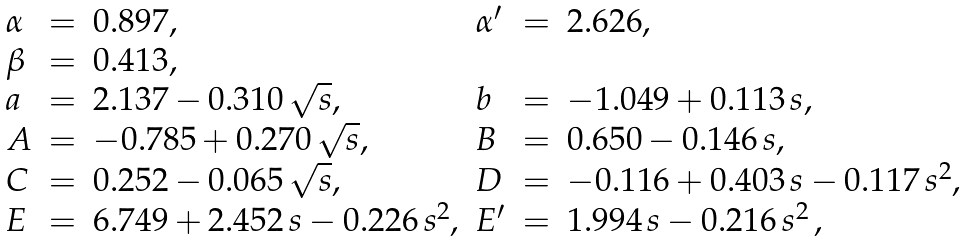Convert formula to latex. <formula><loc_0><loc_0><loc_500><loc_500>\begin{array} { l c l l c l } { \alpha } & { = } & { 0 . 8 9 7 , } & { { \alpha ^ { \prime } } } & { = } & { 2 . 6 2 6 , } \\ { \beta } & { = } & { 0 . 4 1 3 , } \\ { a } & { = } & { { 2 . 1 3 7 - 0 . 3 1 0 \, \sqrt { s } , } } & { b } & { = } & { - 1 . 0 4 9 + 0 . 1 1 3 \, s , } \\ { A } & { = } & { { - 0 . 7 8 5 + 0 . 2 7 0 \, \sqrt { s } , } } & { B } & { = } & { 0 . 6 5 0 - 0 . 1 4 6 \, s , } \\ { C } & { = } & { { 0 . 2 5 2 - 0 . 0 6 5 \, \sqrt { s } , } } & { D } & { = } & { { - 0 . 1 1 6 + 0 . 4 0 3 \, s - 0 . 1 1 7 \, s ^ { 2 } , } } \\ { E } & { = } & { { 6 . 7 4 9 + 2 . 4 5 2 \, s - 0 . 2 2 6 \, s ^ { 2 } , } } & { { E ^ { \prime } } } & { = } & { { 1 . 9 9 4 \, s - 0 . 2 1 6 \, s ^ { 2 } \, , } } \end{array}</formula> 